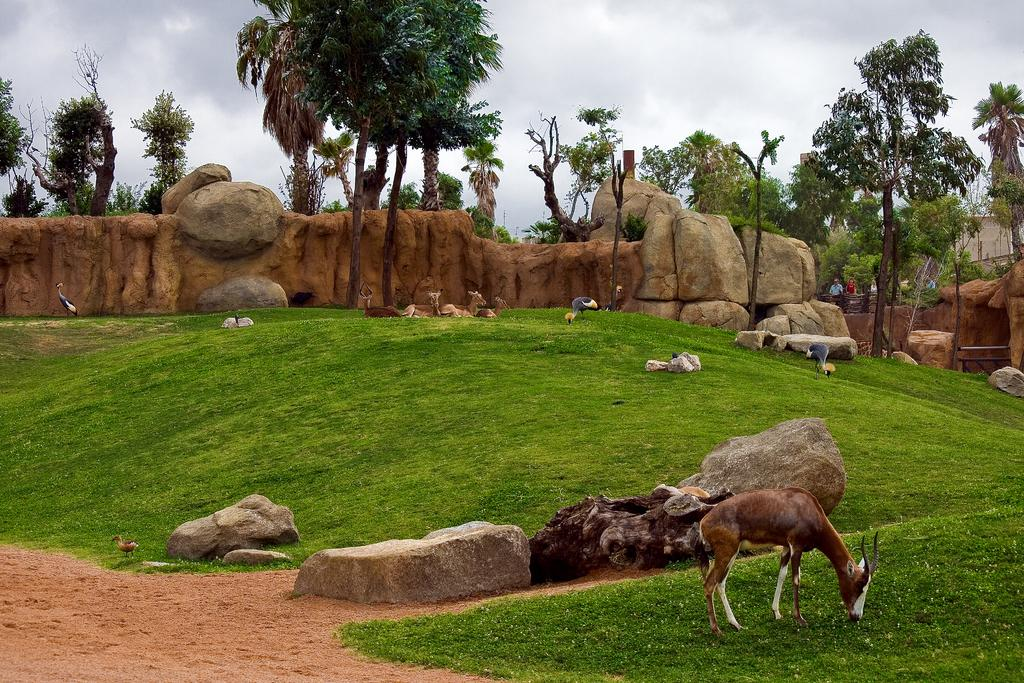What types of living organisms can be seen in the image? There are animals and birds in the image. What are the animals and birds doing in the image? The animals and birds are standing and lying on the ground. What natural elements can be seen in the image? There are stones, rocks, trees, and the sky visible in the image. What is the condition of the sky in the image? The sky is visible in the image, and there are clouds present. Are there any human activities depicted in the image? Yes, there are persons walking in the image. What type of heart can be seen beating in the image? There is no heart visible in the image; it features animals, birds, stones, rocks, trees, the sky, clouds, and persons walking. What is the daughter of the person walking in the image doing? There is no daughter present in the image; it only shows persons walking. 